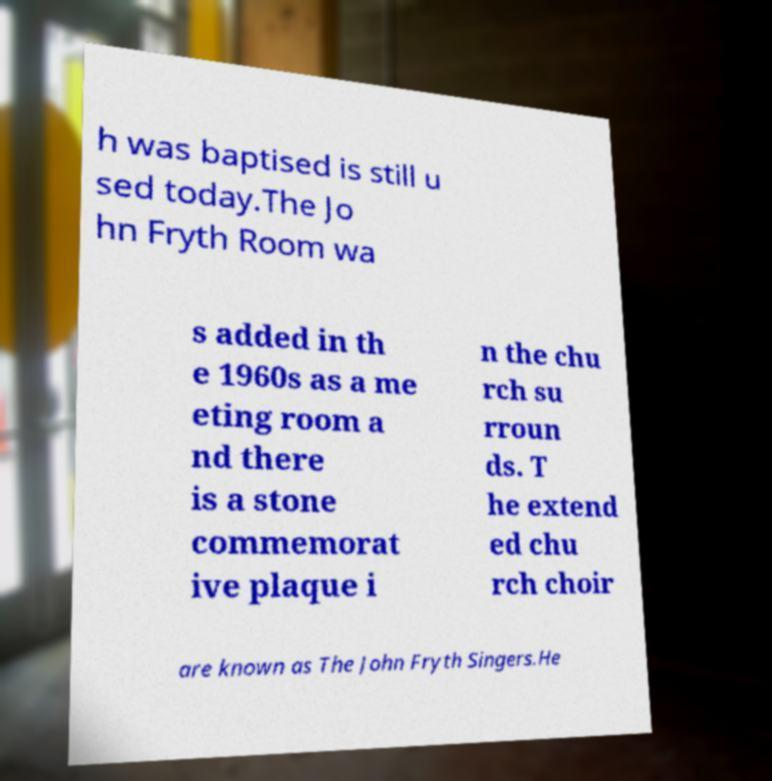What messages or text are displayed in this image? I need them in a readable, typed format. h was baptised is still u sed today.The Jo hn Fryth Room wa s added in th e 1960s as a me eting room a nd there is a stone commemorat ive plaque i n the chu rch su rroun ds. T he extend ed chu rch choir are known as The John Fryth Singers.He 